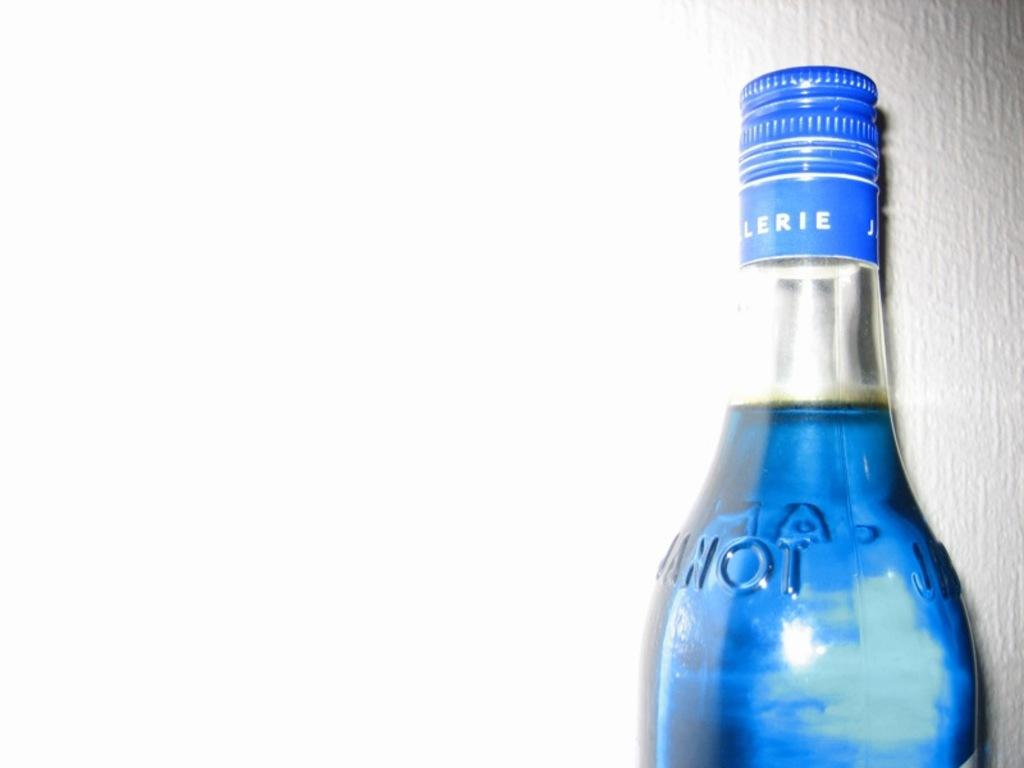<image>
Provide a brief description of the given image. a glass bottle of a blue liquid with Lerie on the cap 